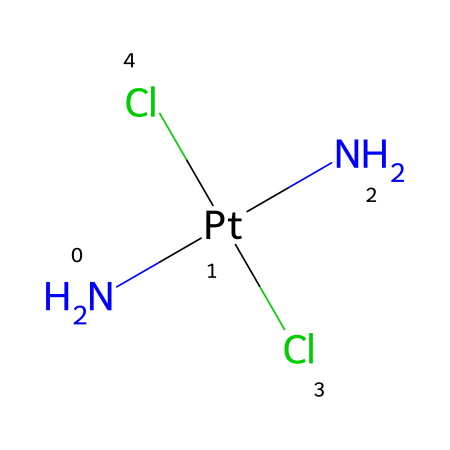What is the central metal ion in this coordination compound? The central metal ion can be identified by looking at the structure. In this case, the symbol "Pt" (platinum) appears after "N" in the SMILES representation, indicating that platinum is the central metal.
Answer: platinum How many chloride ligands are present in cisplatin? The SMILES notation includes “Cl” twice, indicating there are two chloride (Cl) ions bonded to the platinum center.
Answer: two What is the coordination number of the metal in this compound? The coordination number refers to how many ligands are directly bonded to the central metal. Here, there are four substituents (two Cl and two N), leading to a coordination number of four.
Answer: four What type of geometry does cisplatin exhibit? By examining the arrangement of ligands around the platinum, which has a square planar configuration, it is clear that cisplatin exhibits square planar geometry typical for d8 metal complexes.
Answer: square planar What characteristic makes cisplatin an important anticancer drug? Cisplatin's ability to form cross-links with DNA due to its square planar structure allows it to interfere with DNA replication, which is essential for its anticancer properties.
Answer: DNA cross-linking How does the arrangement of ligands in cisplatin affect its function? The specific arrangement of the ligands (cis configuration) allows for effective interaction with DNA, enhancing the drug's ability to inhibit cellular replication. This sterics and spatial arrangement are crucial for its biological activity.
Answer: cis configuration 